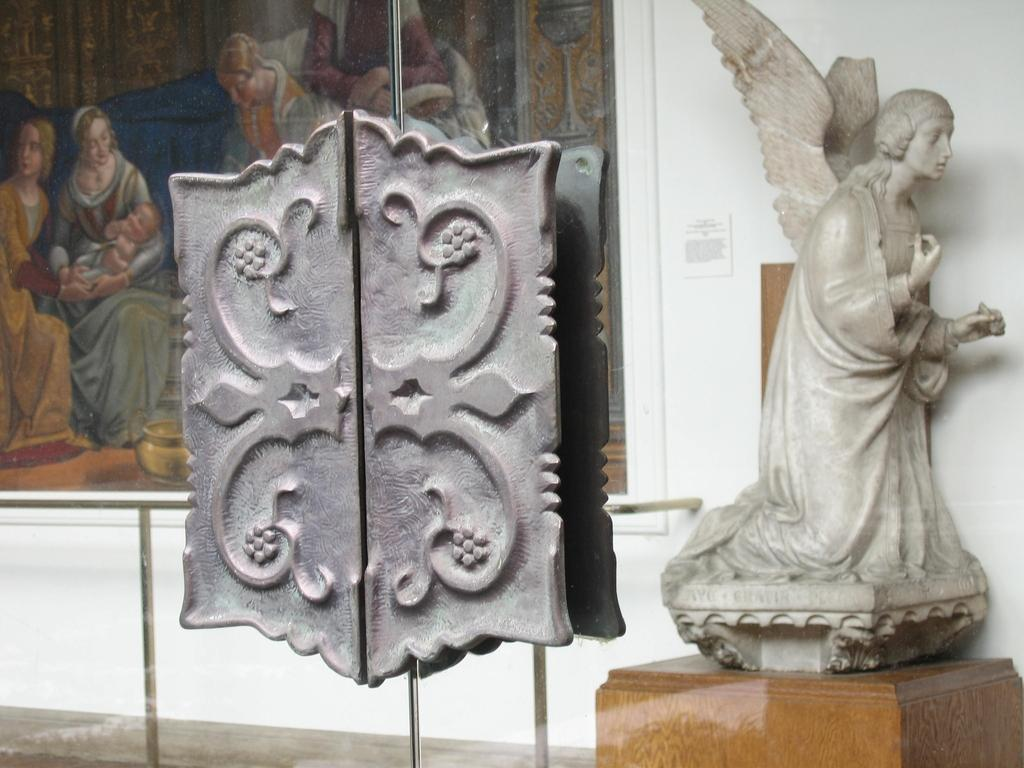What is the main object on the table in the image? There is a statue on a table in the image. What type of door can be seen in the image? There is a glass door in the image. Where is the photo frame located in the image? The photo frame is on a wall in the image. What type of system is the monkey using to communicate with the statue? There is no monkey present in the image, so it is not possible to determine what type of system it might be using to communicate with the statue. 